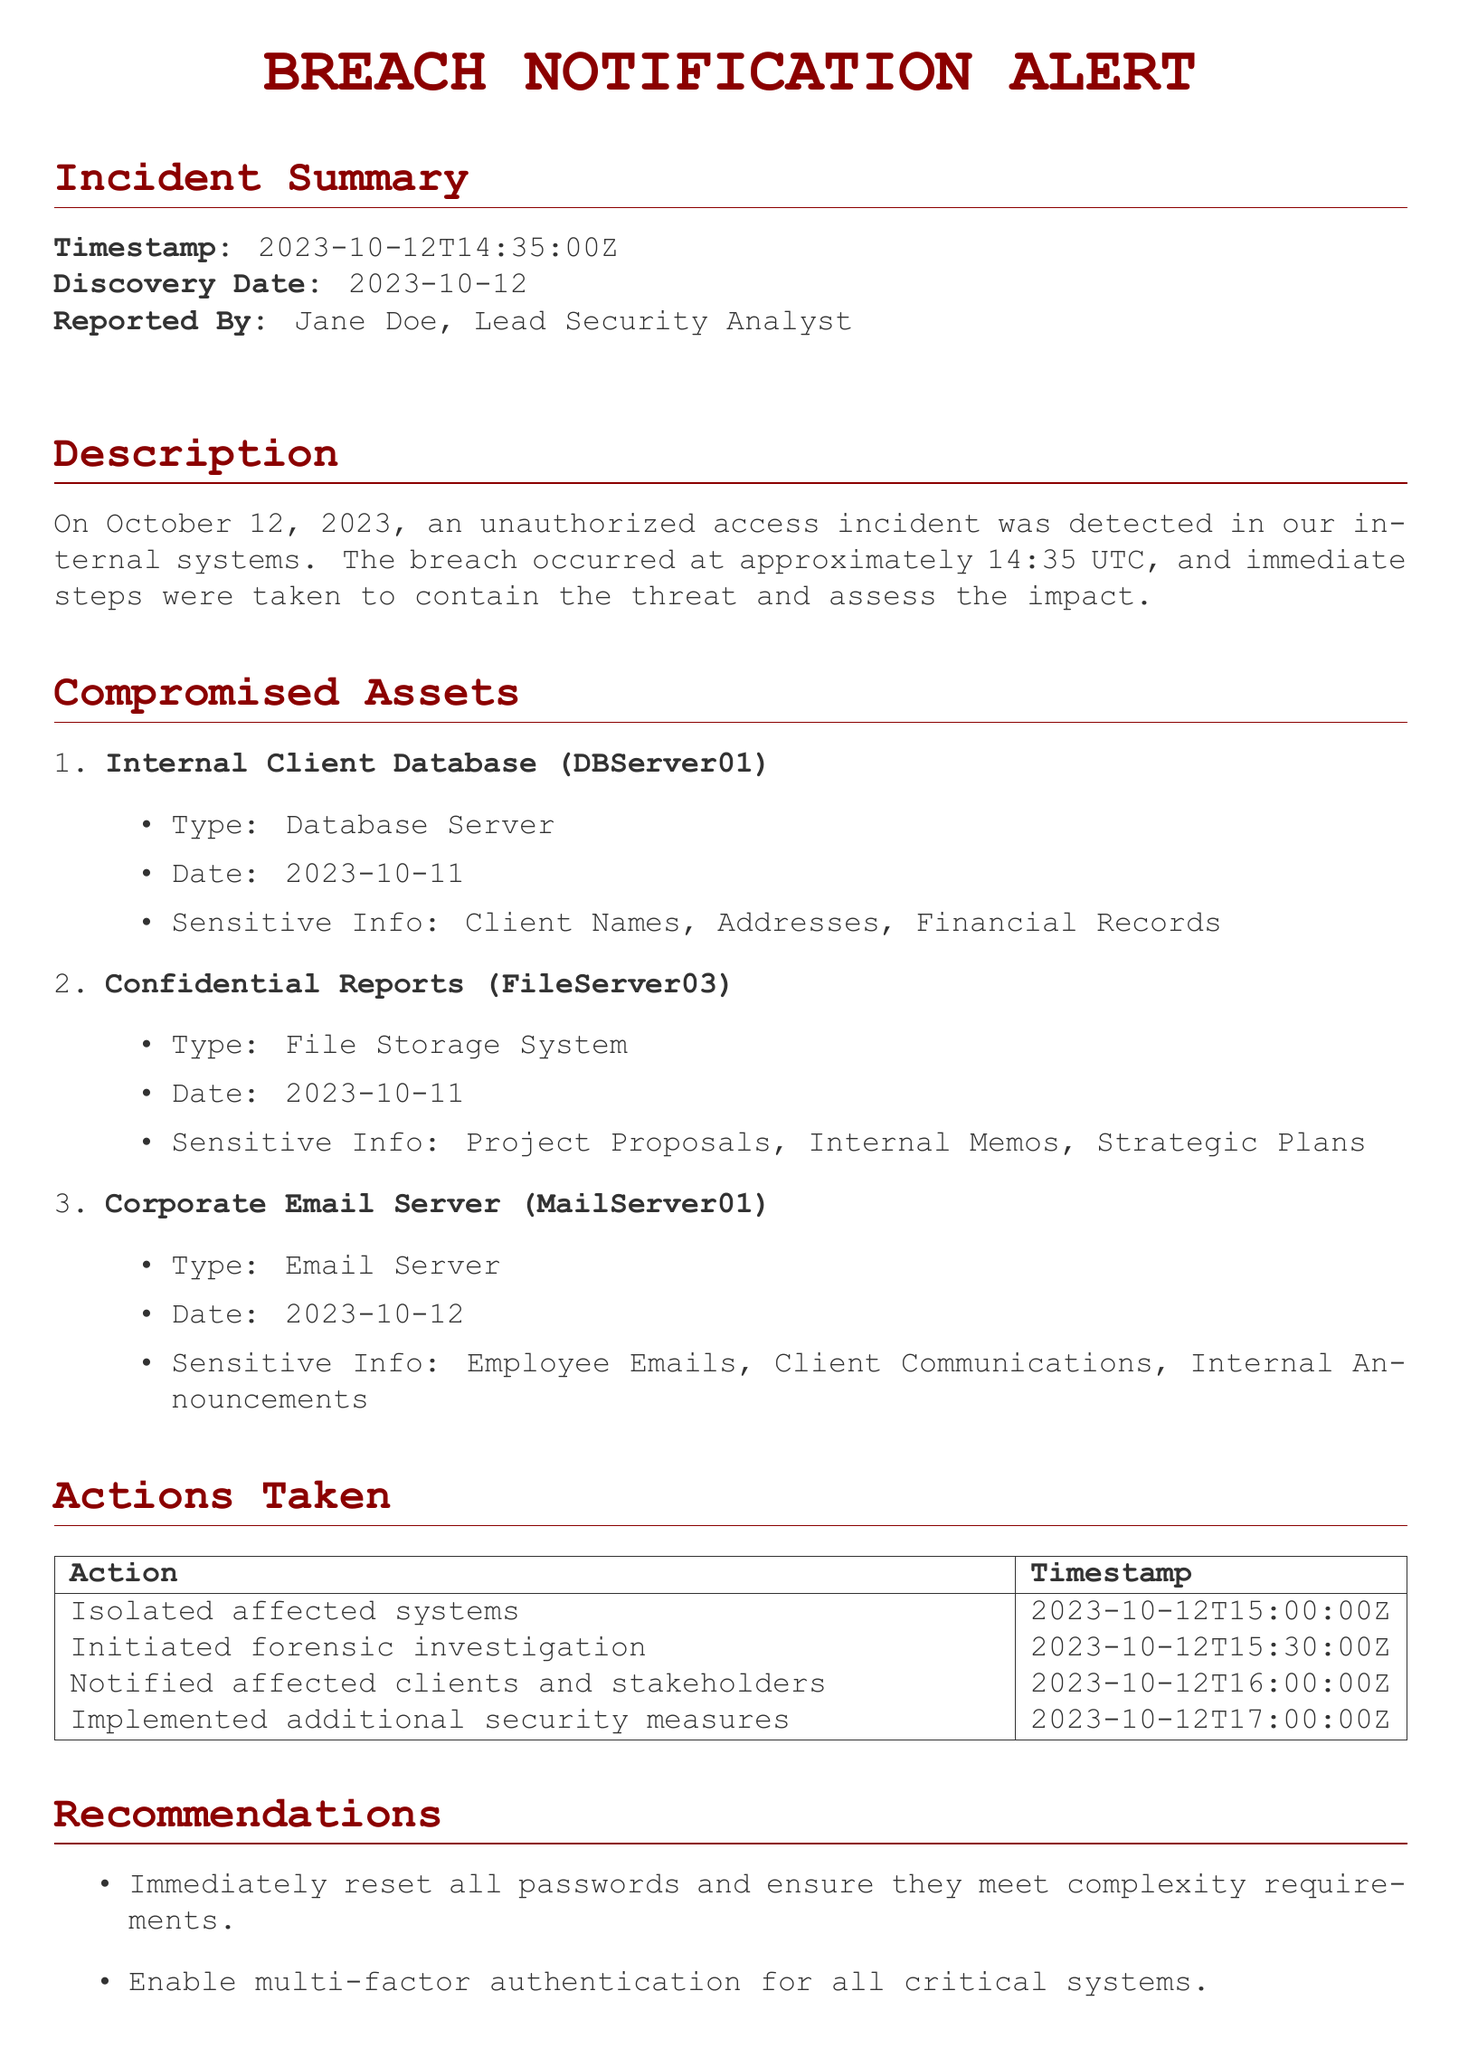What is the discovery date of the breach? The discovery date is clearly stated in the Incident Summary section of the document.
Answer: 2023-10-12 Who reported the incident? The document specifies the reporter's name in the Incident Summary section.
Answer: Jane Doe What was the timestamp of the unauthorized access incident? The timestamp is found in the Incident Summary, indicating when the breach was detected.
Answer: 2023-10-12T14:35:00Z How many compromised assets are listed? The list of compromised assets is provided as an enumerated list, making it easy to count.
Answer: 3 What type of server is DBServer01? The document specifies the type of each compromised asset in their respective details.
Answer: Database Server What action was taken at 15:30 UTC? The document lists actions taken alongside their timestamps, allowing for straightforward retrieval of this information.
Answer: Initiated forensic investigation What sensitive information was compromised with MailServer01? The details under the compromised assets describe the type of sensitive information for each asset.
Answer: Employee Emails, Client Communications, Internal Announcements What is one of the recommendations made in the document? The Recommendations section presents several actions; any one can be answered here.
Answer: Immediately reset all passwords What is the date of the compromised Corporate Email Server? The date of the compromised asset is stated in the description of its details.
Answer: 2023-10-12 